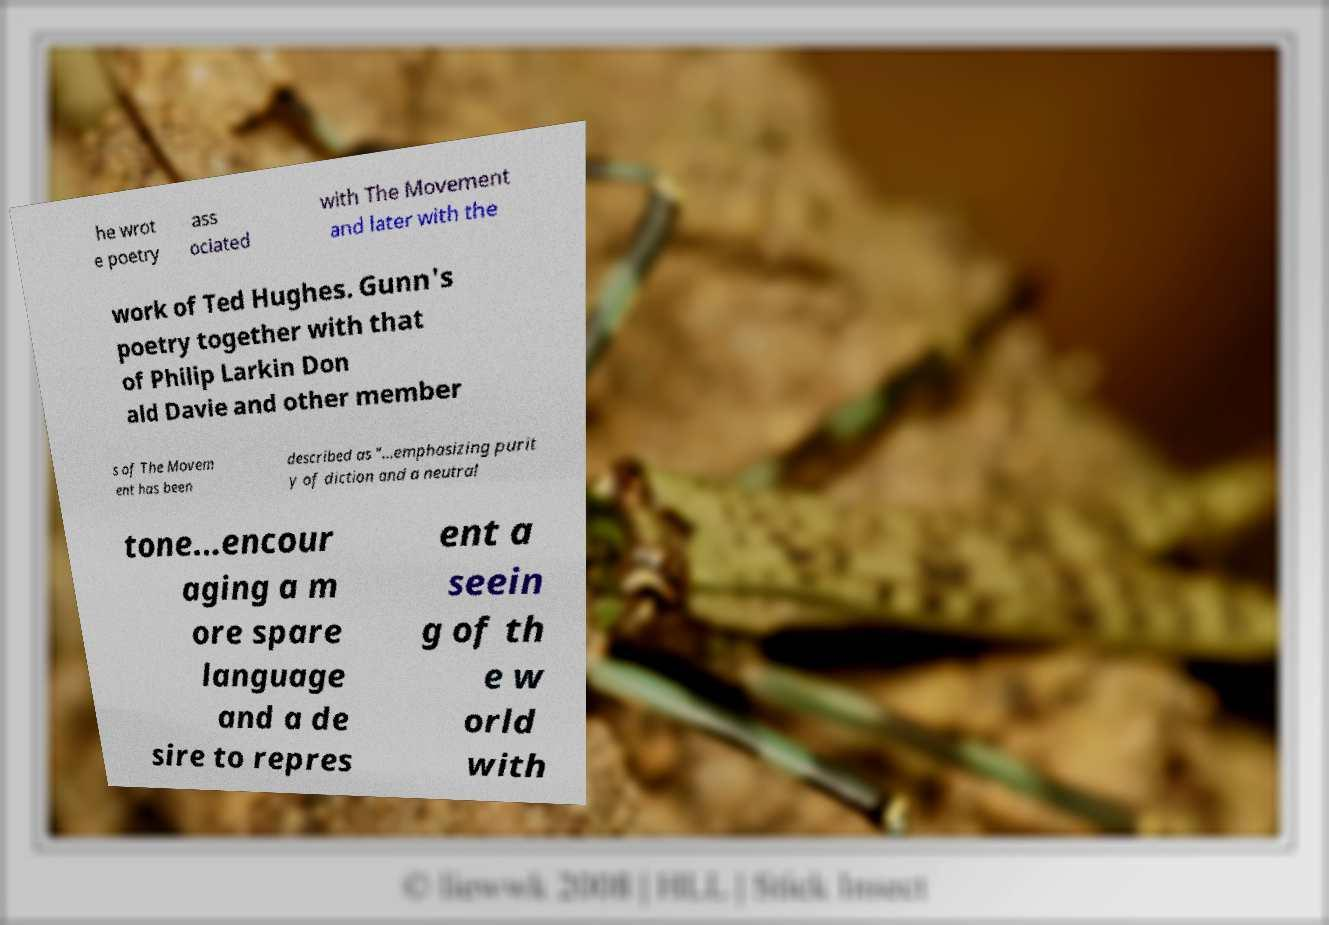Could you assist in decoding the text presented in this image and type it out clearly? he wrot e poetry ass ociated with The Movement and later with the work of Ted Hughes. Gunn's poetry together with that of Philip Larkin Don ald Davie and other member s of The Movem ent has been described as "...emphasizing purit y of diction and a neutral tone...encour aging a m ore spare language and a de sire to repres ent a seein g of th e w orld with 